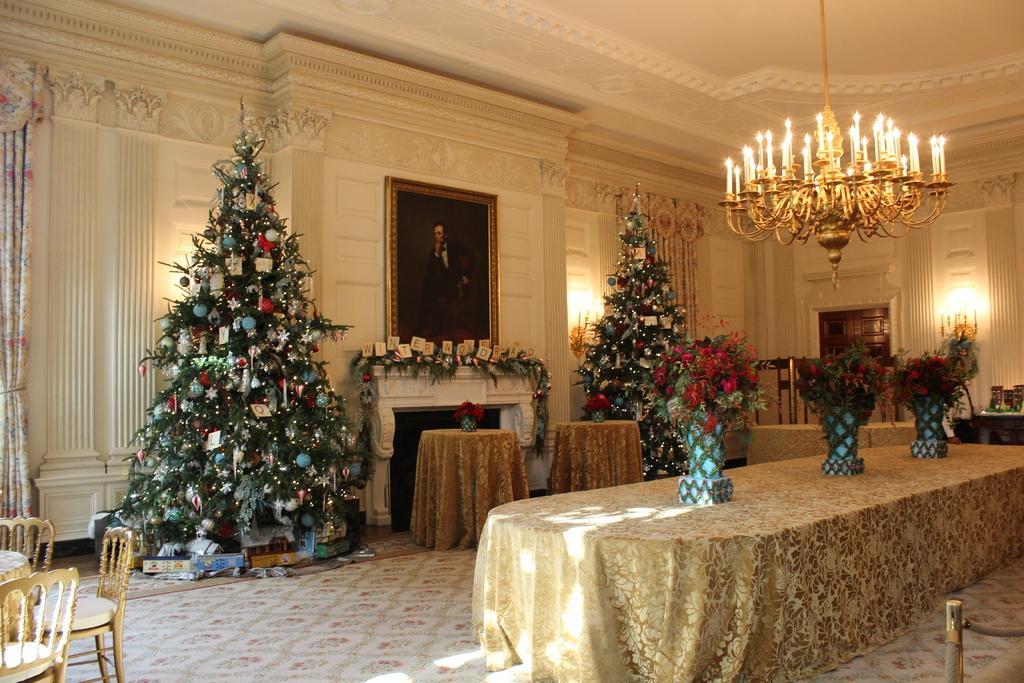Can you describe this image briefly? This image is taken inside a room. There is a table on which there is a cloth and flower bouquets. There is wall with a photo frame. There are Christmas trees. At the top of the image there is ceiling with light. To the left side of the image there are chairs and table. At the bottom of the image there is carpet. To the right side of the image there is safety pole. 